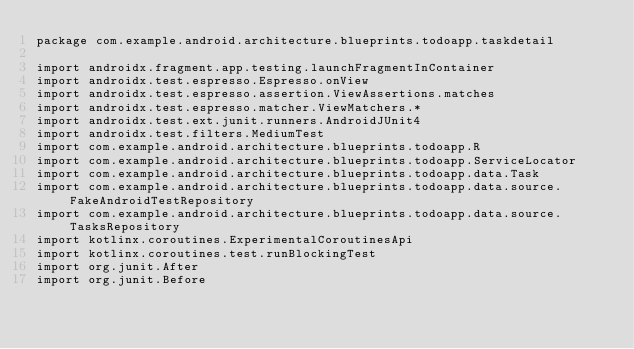Convert code to text. <code><loc_0><loc_0><loc_500><loc_500><_Kotlin_>package com.example.android.architecture.blueprints.todoapp.taskdetail

import androidx.fragment.app.testing.launchFragmentInContainer
import androidx.test.espresso.Espresso.onView
import androidx.test.espresso.assertion.ViewAssertions.matches
import androidx.test.espresso.matcher.ViewMatchers.*
import androidx.test.ext.junit.runners.AndroidJUnit4
import androidx.test.filters.MediumTest
import com.example.android.architecture.blueprints.todoapp.R
import com.example.android.architecture.blueprints.todoapp.ServiceLocator
import com.example.android.architecture.blueprints.todoapp.data.Task
import com.example.android.architecture.blueprints.todoapp.data.source.FakeAndroidTestRepository
import com.example.android.architecture.blueprints.todoapp.data.source.TasksRepository
import kotlinx.coroutines.ExperimentalCoroutinesApi
import kotlinx.coroutines.test.runBlockingTest
import org.junit.After
import org.junit.Before</code> 